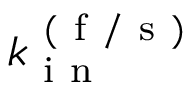<formula> <loc_0><loc_0><loc_500><loc_500>k _ { i n } ^ { ( f / s ) }</formula> 